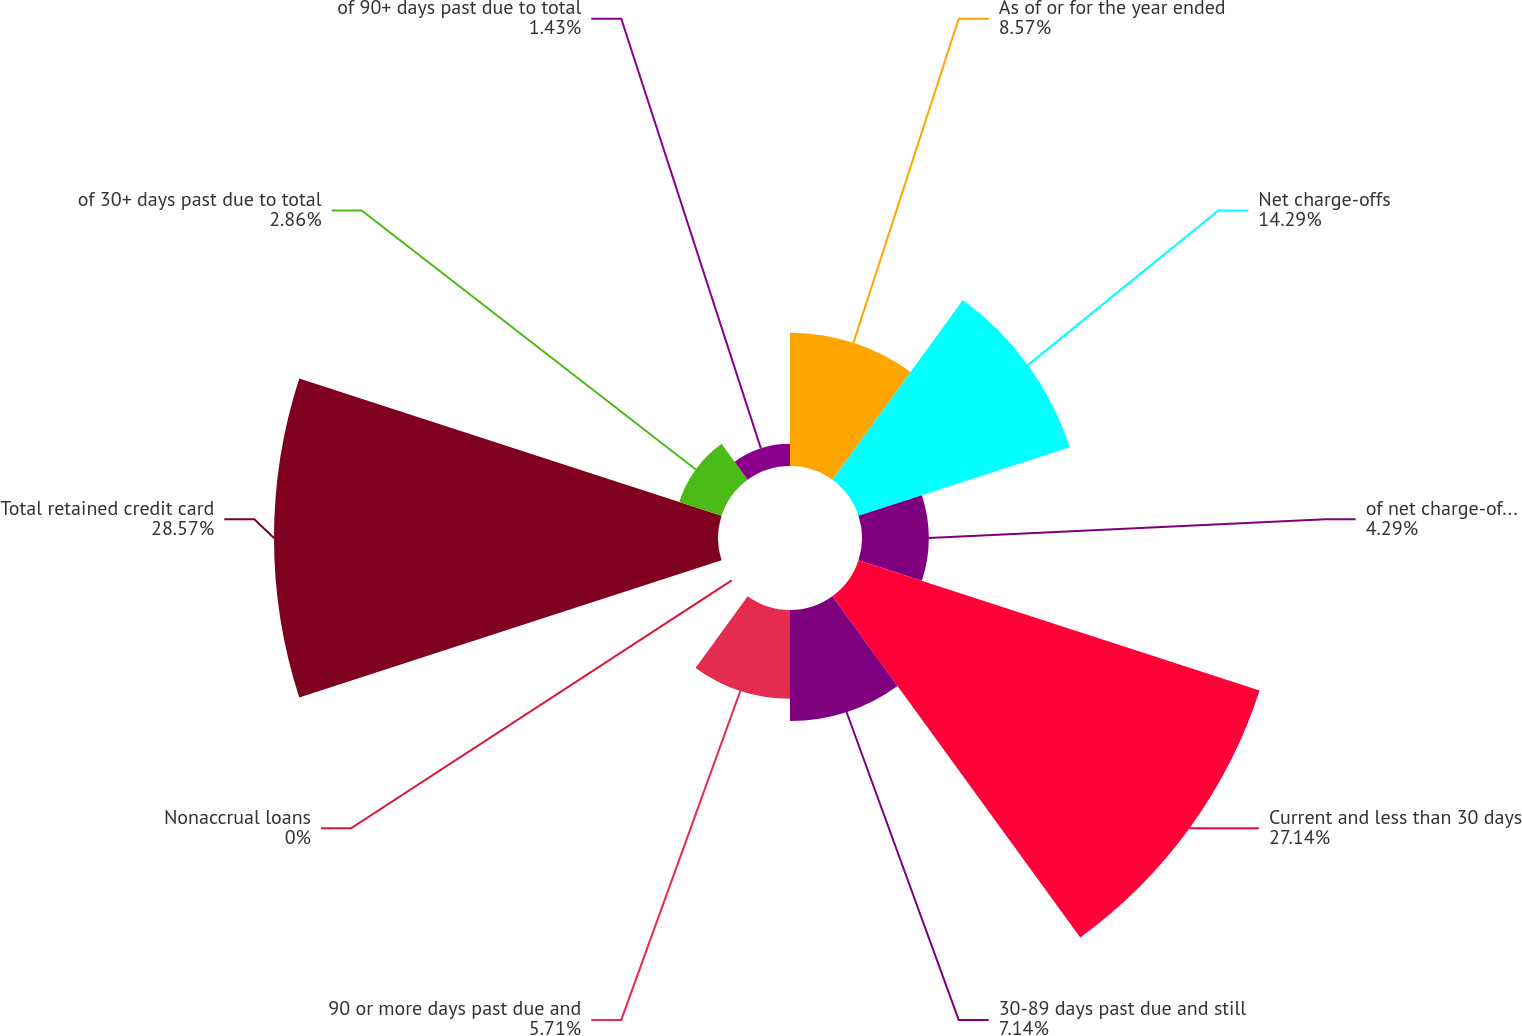<chart> <loc_0><loc_0><loc_500><loc_500><pie_chart><fcel>As of or for the year ended<fcel>Net charge-offs<fcel>of net charge-offs to retained<fcel>Current and less than 30 days<fcel>30-89 days past due and still<fcel>90 or more days past due and<fcel>Nonaccrual loans<fcel>Total retained credit card<fcel>of 30+ days past due to total<fcel>of 90+ days past due to total<nl><fcel>8.57%<fcel>14.29%<fcel>4.29%<fcel>27.14%<fcel>7.14%<fcel>5.71%<fcel>0.0%<fcel>28.57%<fcel>2.86%<fcel>1.43%<nl></chart> 